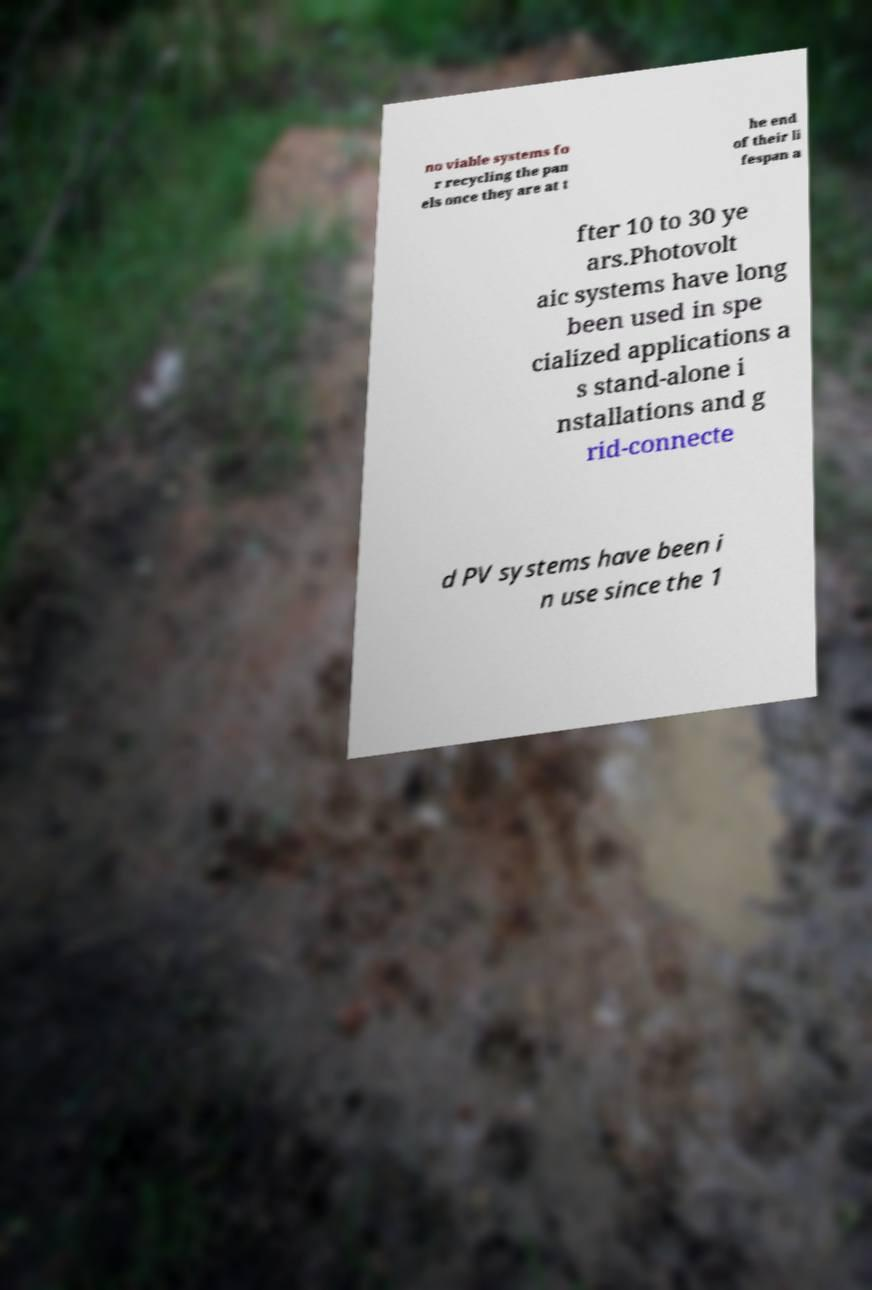Can you accurately transcribe the text from the provided image for me? no viable systems fo r recycling the pan els once they are at t he end of their li fespan a fter 10 to 30 ye ars.Photovolt aic systems have long been used in spe cialized applications a s stand-alone i nstallations and g rid-connecte d PV systems have been i n use since the 1 